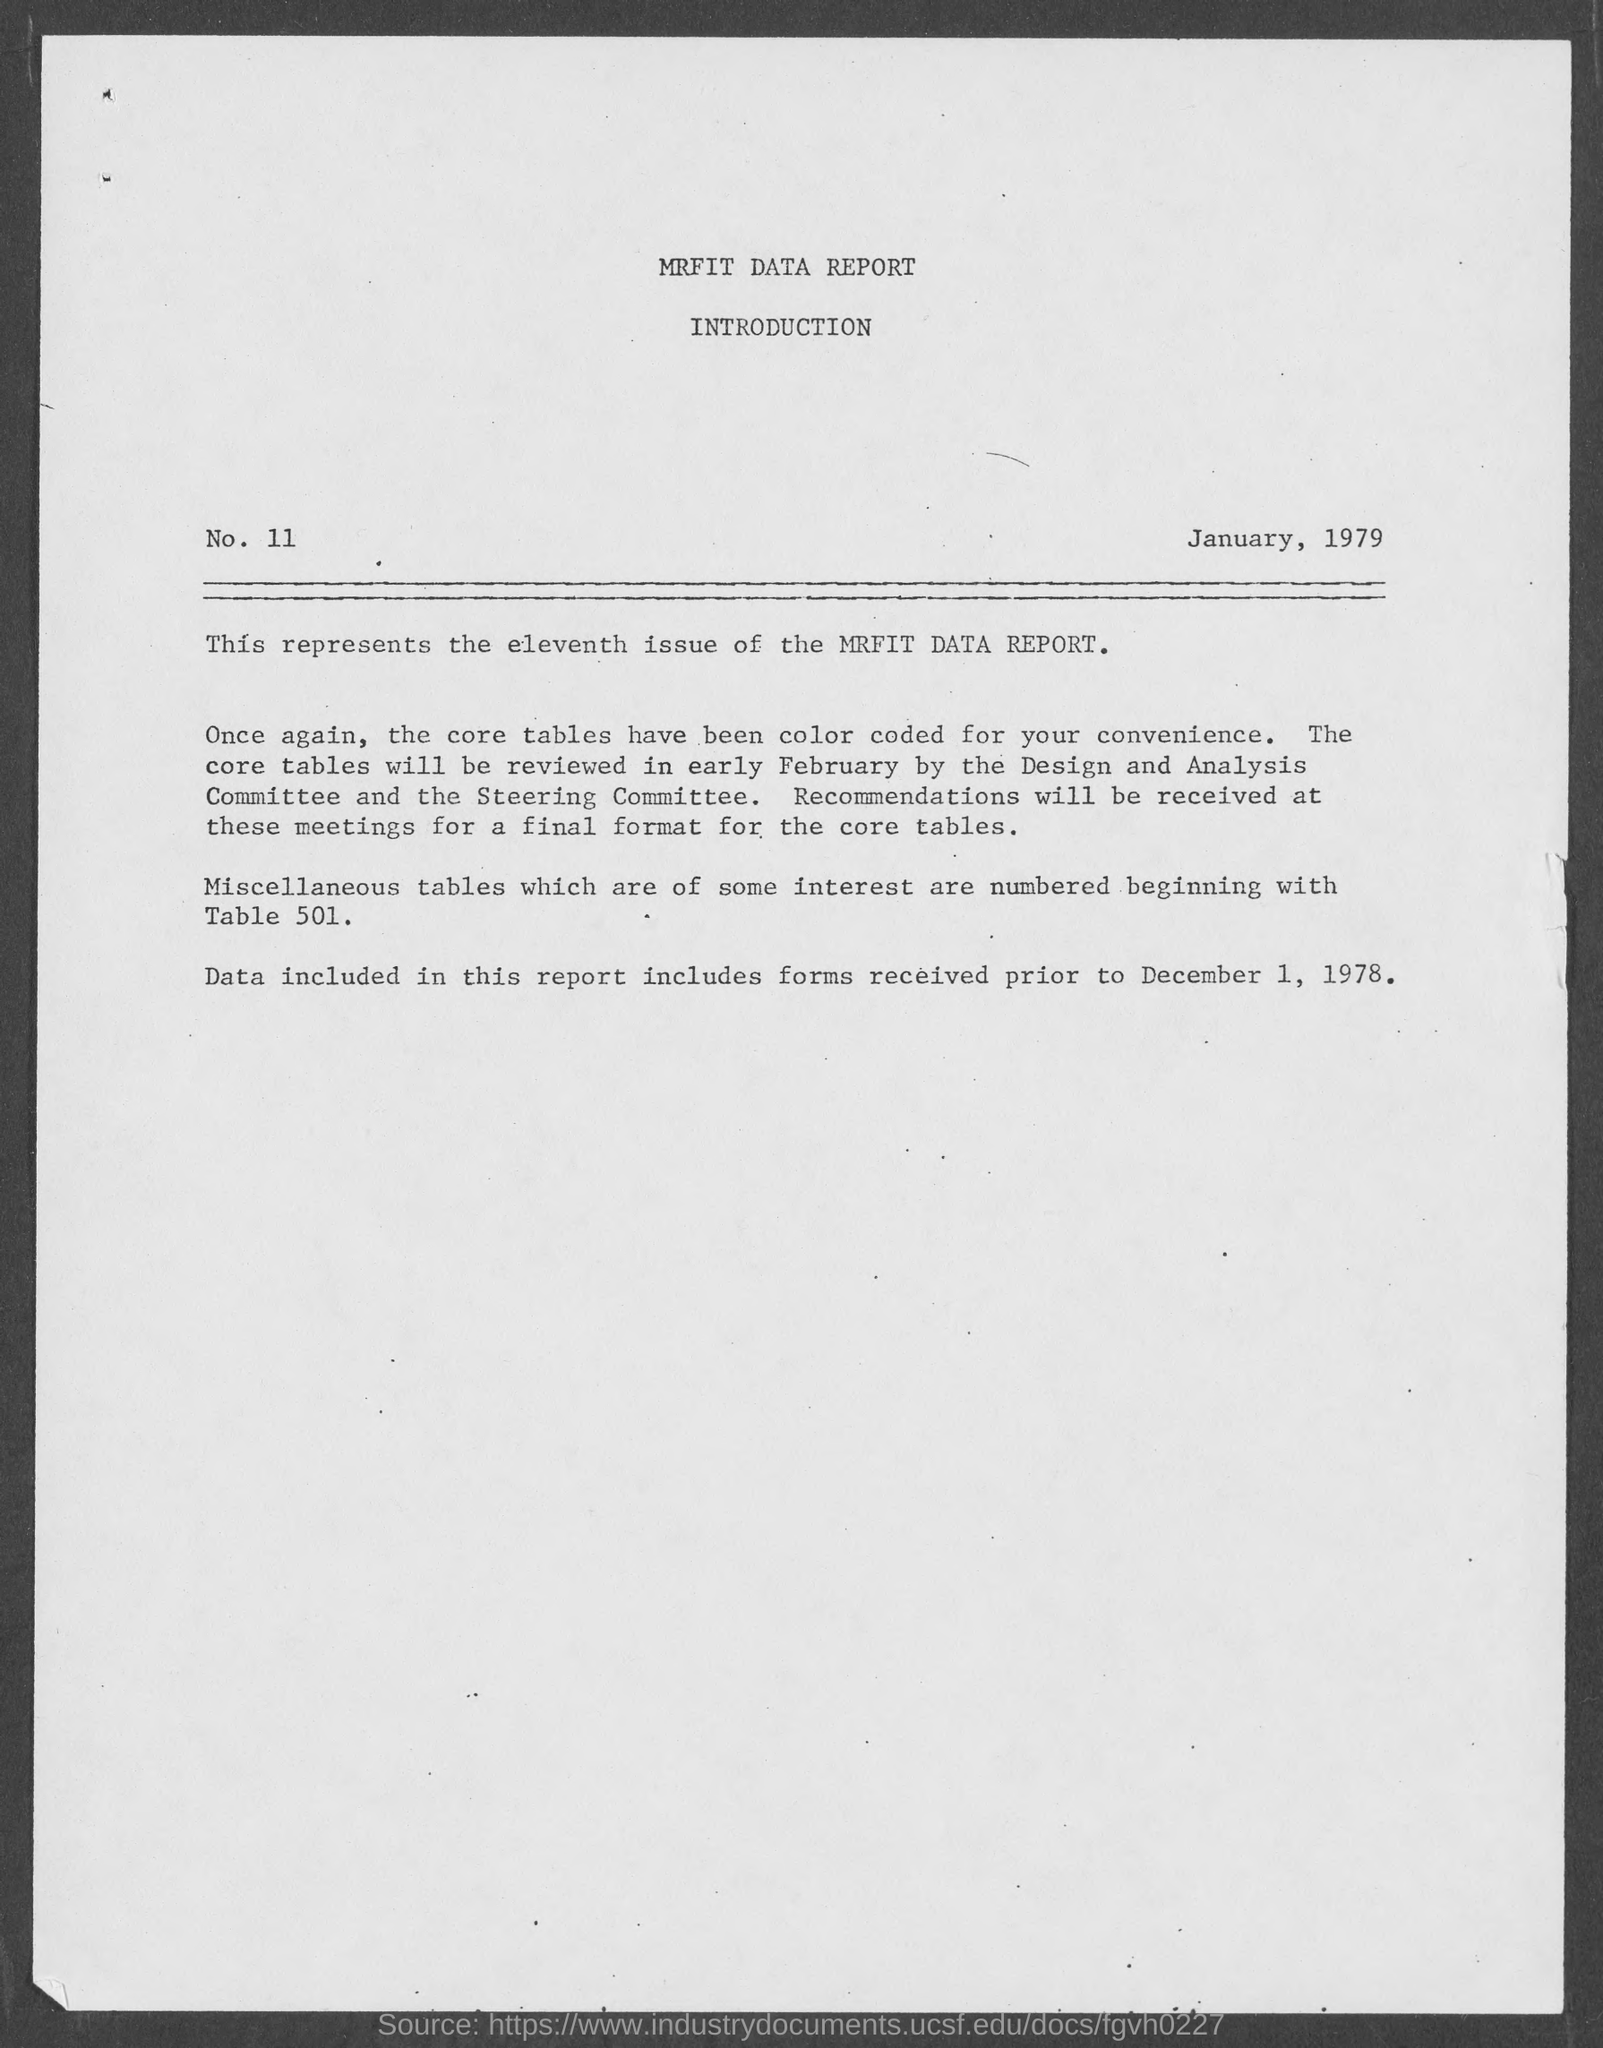Outline some significant characteristics in this image. The date on the report is January 1979. The MRFIT  DATA REPORT is shown to contain the eleventh issue. The title of the MRFIT DATA REPORT is [MRFIT DATA REPORT]. 